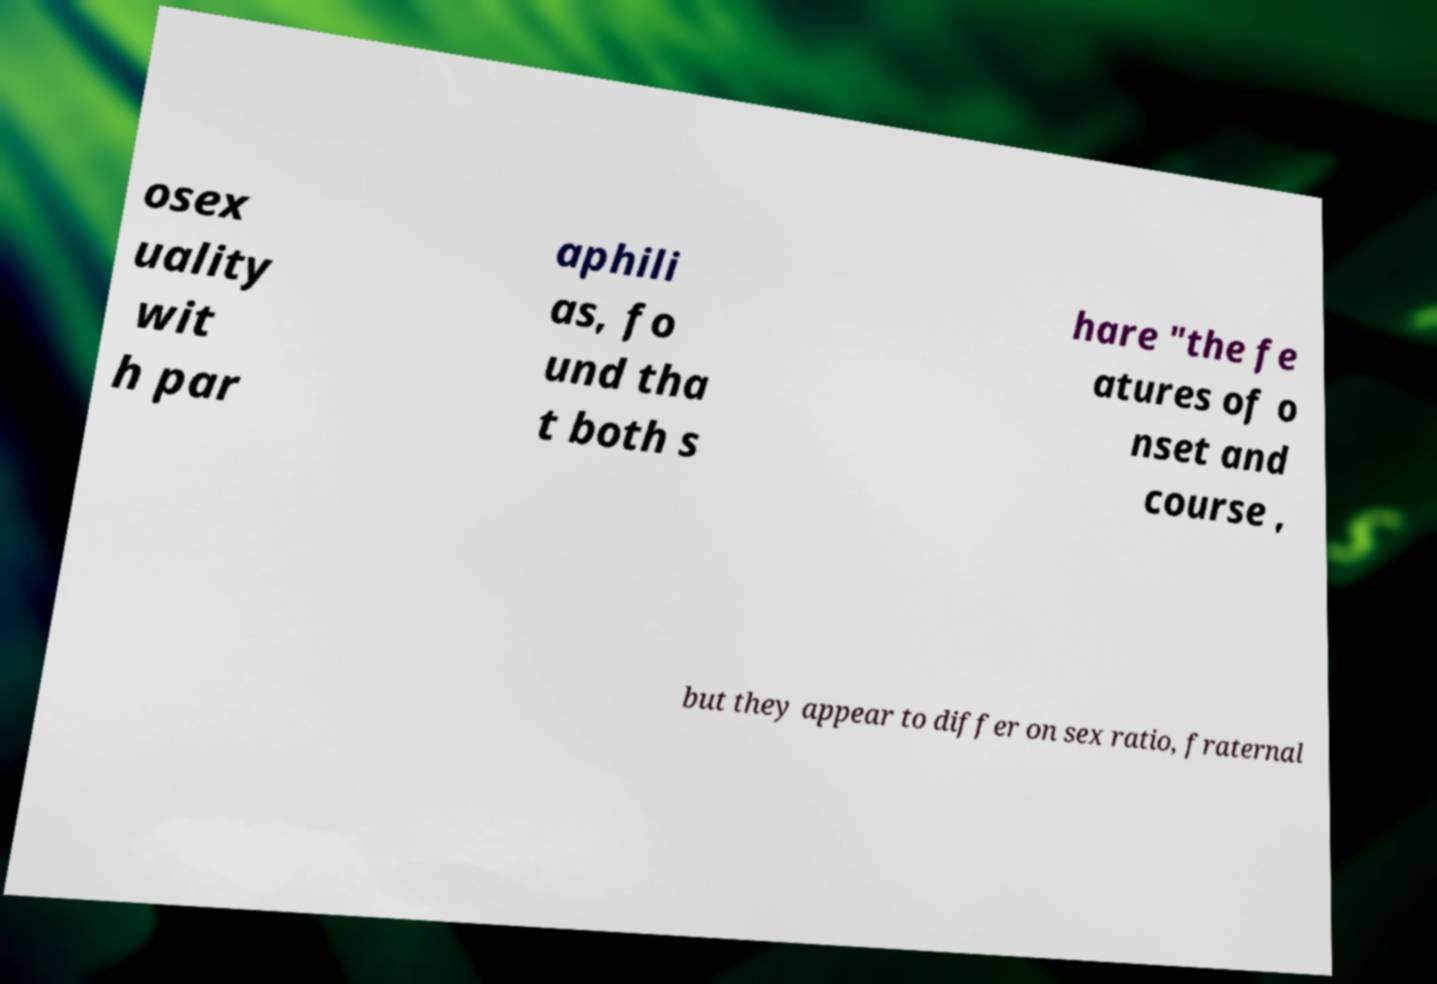Please read and relay the text visible in this image. What does it say? osex uality wit h par aphili as, fo und tha t both s hare "the fe atures of o nset and course , but they appear to differ on sex ratio, fraternal 